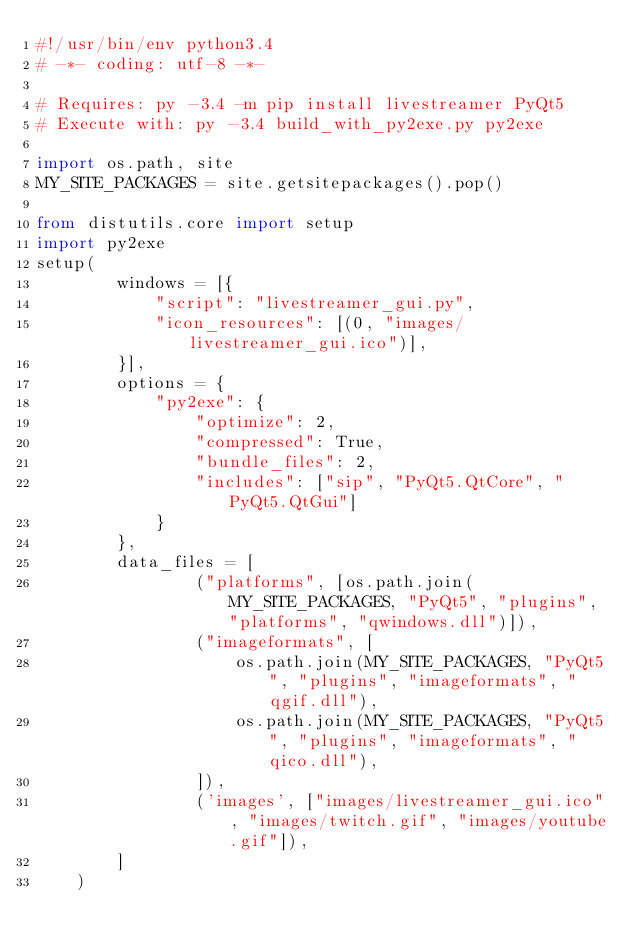Convert code to text. <code><loc_0><loc_0><loc_500><loc_500><_Python_>#!/usr/bin/env python3.4
# -*- coding: utf-8 -*-

# Requires: py -3.4 -m pip install livestreamer PyQt5
# Execute with: py -3.4 build_with_py2exe.py py2exe

import os.path, site
MY_SITE_PACKAGES = site.getsitepackages().pop()

from distutils.core import setup
import py2exe
setup(
		windows = [{
			"script": "livestreamer_gui.py",
			"icon_resources": [(0, "images/livestreamer_gui.ico")],
		}],
		options = {
			"py2exe": {
				"optimize": 2,
				"compressed": True,
				"bundle_files": 2,
				"includes": ["sip", "PyQt5.QtCore", "PyQt5.QtGui"]
			}
		},
		data_files = [
				("platforms", [os.path.join(MY_SITE_PACKAGES, "PyQt5", "plugins", "platforms", "qwindows.dll")]),
				("imageformats", [
					os.path.join(MY_SITE_PACKAGES, "PyQt5", "plugins", "imageformats", "qgif.dll"),
					os.path.join(MY_SITE_PACKAGES, "PyQt5", "plugins", "imageformats", "qico.dll"),
				]),
				('images', ["images/livestreamer_gui.ico", "images/twitch.gif", "images/youtube.gif"]),
		]
	)
</code> 